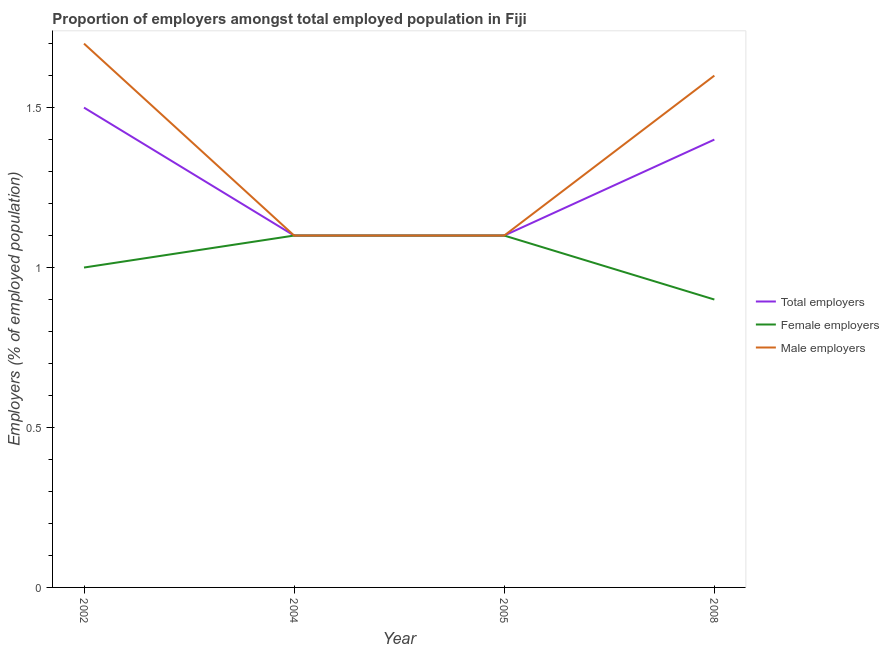How many different coloured lines are there?
Give a very brief answer. 3. Is the number of lines equal to the number of legend labels?
Your answer should be compact. Yes. What is the percentage of female employers in 2005?
Offer a very short reply. 1.1. Across all years, what is the minimum percentage of male employers?
Make the answer very short. 1.1. In which year was the percentage of total employers maximum?
Your answer should be very brief. 2002. What is the total percentage of total employers in the graph?
Ensure brevity in your answer.  5.1. What is the difference between the percentage of female employers in 2005 and that in 2008?
Ensure brevity in your answer.  0.2. What is the difference between the percentage of total employers in 2004 and the percentage of female employers in 2005?
Keep it short and to the point. 0. What is the average percentage of male employers per year?
Keep it short and to the point. 1.38. In the year 2008, what is the difference between the percentage of female employers and percentage of male employers?
Offer a very short reply. -0.7. In how many years, is the percentage of female employers greater than 0.7 %?
Your response must be concise. 4. What is the ratio of the percentage of male employers in 2005 to that in 2008?
Offer a terse response. 0.69. Is the percentage of male employers in 2002 less than that in 2008?
Give a very brief answer. No. What is the difference between the highest and the second highest percentage of total employers?
Keep it short and to the point. 0.1. What is the difference between the highest and the lowest percentage of total employers?
Your response must be concise. 0.4. In how many years, is the percentage of male employers greater than the average percentage of male employers taken over all years?
Provide a succinct answer. 2. Is the percentage of female employers strictly greater than the percentage of total employers over the years?
Your answer should be very brief. No. Is the percentage of female employers strictly less than the percentage of male employers over the years?
Your answer should be very brief. No. How many lines are there?
Your response must be concise. 3. How many years are there in the graph?
Your response must be concise. 4. Does the graph contain grids?
Give a very brief answer. No. How are the legend labels stacked?
Your response must be concise. Vertical. What is the title of the graph?
Offer a very short reply. Proportion of employers amongst total employed population in Fiji. What is the label or title of the Y-axis?
Give a very brief answer. Employers (% of employed population). What is the Employers (% of employed population) of Male employers in 2002?
Your answer should be compact. 1.7. What is the Employers (% of employed population) of Total employers in 2004?
Your answer should be compact. 1.1. What is the Employers (% of employed population) in Female employers in 2004?
Make the answer very short. 1.1. What is the Employers (% of employed population) of Male employers in 2004?
Offer a terse response. 1.1. What is the Employers (% of employed population) of Total employers in 2005?
Your response must be concise. 1.1. What is the Employers (% of employed population) in Female employers in 2005?
Your answer should be compact. 1.1. What is the Employers (% of employed population) in Male employers in 2005?
Offer a very short reply. 1.1. What is the Employers (% of employed population) in Total employers in 2008?
Make the answer very short. 1.4. What is the Employers (% of employed population) of Female employers in 2008?
Keep it short and to the point. 0.9. What is the Employers (% of employed population) of Male employers in 2008?
Provide a succinct answer. 1.6. Across all years, what is the maximum Employers (% of employed population) in Female employers?
Your answer should be very brief. 1.1. Across all years, what is the maximum Employers (% of employed population) in Male employers?
Ensure brevity in your answer.  1.7. Across all years, what is the minimum Employers (% of employed population) of Total employers?
Your answer should be very brief. 1.1. Across all years, what is the minimum Employers (% of employed population) of Female employers?
Provide a succinct answer. 0.9. Across all years, what is the minimum Employers (% of employed population) in Male employers?
Offer a terse response. 1.1. What is the total Employers (% of employed population) in Female employers in the graph?
Offer a very short reply. 4.1. What is the difference between the Employers (% of employed population) of Female employers in 2002 and that in 2004?
Keep it short and to the point. -0.1. What is the difference between the Employers (% of employed population) in Male employers in 2002 and that in 2004?
Provide a short and direct response. 0.6. What is the difference between the Employers (% of employed population) in Total employers in 2002 and that in 2005?
Your response must be concise. 0.4. What is the difference between the Employers (% of employed population) of Female employers in 2002 and that in 2005?
Provide a succinct answer. -0.1. What is the difference between the Employers (% of employed population) of Male employers in 2002 and that in 2005?
Your answer should be compact. 0.6. What is the difference between the Employers (% of employed population) of Female employers in 2002 and that in 2008?
Give a very brief answer. 0.1. What is the difference between the Employers (% of employed population) of Male employers in 2002 and that in 2008?
Provide a succinct answer. 0.1. What is the difference between the Employers (% of employed population) in Male employers in 2004 and that in 2008?
Offer a very short reply. -0.5. What is the difference between the Employers (% of employed population) in Total employers in 2002 and the Employers (% of employed population) in Female employers in 2004?
Give a very brief answer. 0.4. What is the difference between the Employers (% of employed population) in Female employers in 2002 and the Employers (% of employed population) in Male employers in 2004?
Offer a very short reply. -0.1. What is the difference between the Employers (% of employed population) of Total employers in 2002 and the Employers (% of employed population) of Male employers in 2005?
Offer a terse response. 0.4. What is the difference between the Employers (% of employed population) in Female employers in 2002 and the Employers (% of employed population) in Male employers in 2005?
Make the answer very short. -0.1. What is the difference between the Employers (% of employed population) in Total employers in 2002 and the Employers (% of employed population) in Female employers in 2008?
Offer a very short reply. 0.6. What is the difference between the Employers (% of employed population) of Total employers in 2004 and the Employers (% of employed population) of Female employers in 2005?
Provide a succinct answer. 0. What is the average Employers (% of employed population) in Total employers per year?
Provide a succinct answer. 1.27. What is the average Employers (% of employed population) in Female employers per year?
Your answer should be very brief. 1.02. What is the average Employers (% of employed population) in Male employers per year?
Provide a succinct answer. 1.38. In the year 2002, what is the difference between the Employers (% of employed population) of Total employers and Employers (% of employed population) of Female employers?
Your answer should be compact. 0.5. In the year 2002, what is the difference between the Employers (% of employed population) in Female employers and Employers (% of employed population) in Male employers?
Provide a succinct answer. -0.7. In the year 2004, what is the difference between the Employers (% of employed population) of Total employers and Employers (% of employed population) of Male employers?
Give a very brief answer. 0. In the year 2004, what is the difference between the Employers (% of employed population) in Female employers and Employers (% of employed population) in Male employers?
Offer a very short reply. 0. In the year 2005, what is the difference between the Employers (% of employed population) in Total employers and Employers (% of employed population) in Female employers?
Offer a very short reply. 0. In the year 2005, what is the difference between the Employers (% of employed population) of Total employers and Employers (% of employed population) of Male employers?
Your response must be concise. 0. In the year 2008, what is the difference between the Employers (% of employed population) in Total employers and Employers (% of employed population) in Female employers?
Offer a terse response. 0.5. In the year 2008, what is the difference between the Employers (% of employed population) of Total employers and Employers (% of employed population) of Male employers?
Your response must be concise. -0.2. In the year 2008, what is the difference between the Employers (% of employed population) in Female employers and Employers (% of employed population) in Male employers?
Offer a terse response. -0.7. What is the ratio of the Employers (% of employed population) of Total employers in 2002 to that in 2004?
Your response must be concise. 1.36. What is the ratio of the Employers (% of employed population) of Male employers in 2002 to that in 2004?
Offer a terse response. 1.55. What is the ratio of the Employers (% of employed population) in Total employers in 2002 to that in 2005?
Keep it short and to the point. 1.36. What is the ratio of the Employers (% of employed population) in Male employers in 2002 to that in 2005?
Provide a succinct answer. 1.55. What is the ratio of the Employers (% of employed population) of Total employers in 2002 to that in 2008?
Your answer should be very brief. 1.07. What is the ratio of the Employers (% of employed population) of Female employers in 2002 to that in 2008?
Your answer should be compact. 1.11. What is the ratio of the Employers (% of employed population) of Total employers in 2004 to that in 2005?
Your answer should be very brief. 1. What is the ratio of the Employers (% of employed population) of Total employers in 2004 to that in 2008?
Make the answer very short. 0.79. What is the ratio of the Employers (% of employed population) in Female employers in 2004 to that in 2008?
Keep it short and to the point. 1.22. What is the ratio of the Employers (% of employed population) of Male employers in 2004 to that in 2008?
Make the answer very short. 0.69. What is the ratio of the Employers (% of employed population) of Total employers in 2005 to that in 2008?
Offer a very short reply. 0.79. What is the ratio of the Employers (% of employed population) of Female employers in 2005 to that in 2008?
Your answer should be very brief. 1.22. What is the ratio of the Employers (% of employed population) of Male employers in 2005 to that in 2008?
Provide a succinct answer. 0.69. What is the difference between the highest and the second highest Employers (% of employed population) of Male employers?
Offer a terse response. 0.1. What is the difference between the highest and the lowest Employers (% of employed population) in Male employers?
Make the answer very short. 0.6. 